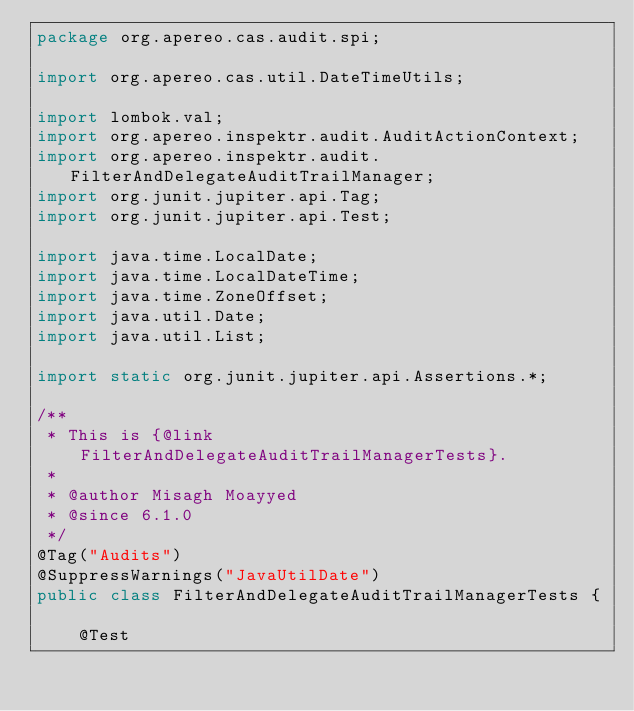<code> <loc_0><loc_0><loc_500><loc_500><_Java_>package org.apereo.cas.audit.spi;

import org.apereo.cas.util.DateTimeUtils;

import lombok.val;
import org.apereo.inspektr.audit.AuditActionContext;
import org.apereo.inspektr.audit.FilterAndDelegateAuditTrailManager;
import org.junit.jupiter.api.Tag;
import org.junit.jupiter.api.Test;

import java.time.LocalDate;
import java.time.LocalDateTime;
import java.time.ZoneOffset;
import java.util.Date;
import java.util.List;

import static org.junit.jupiter.api.Assertions.*;

/**
 * This is {@link FilterAndDelegateAuditTrailManagerTests}.
 *
 * @author Misagh Moayyed
 * @since 6.1.0
 */
@Tag("Audits")
@SuppressWarnings("JavaUtilDate")
public class FilterAndDelegateAuditTrailManagerTests {

    @Test</code> 